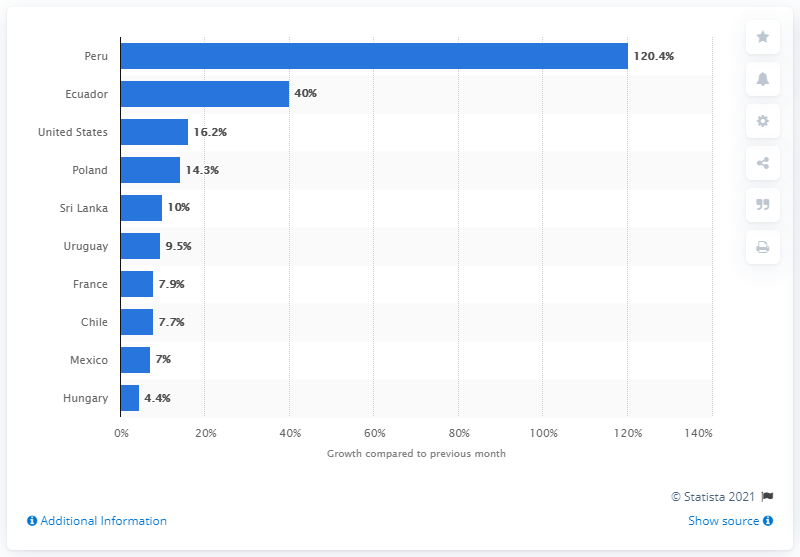Give some essential details in this illustration. In February 2021, there was a significant increase in the number of downloads of TikTok, with a total of 120.4 downloads reported. 